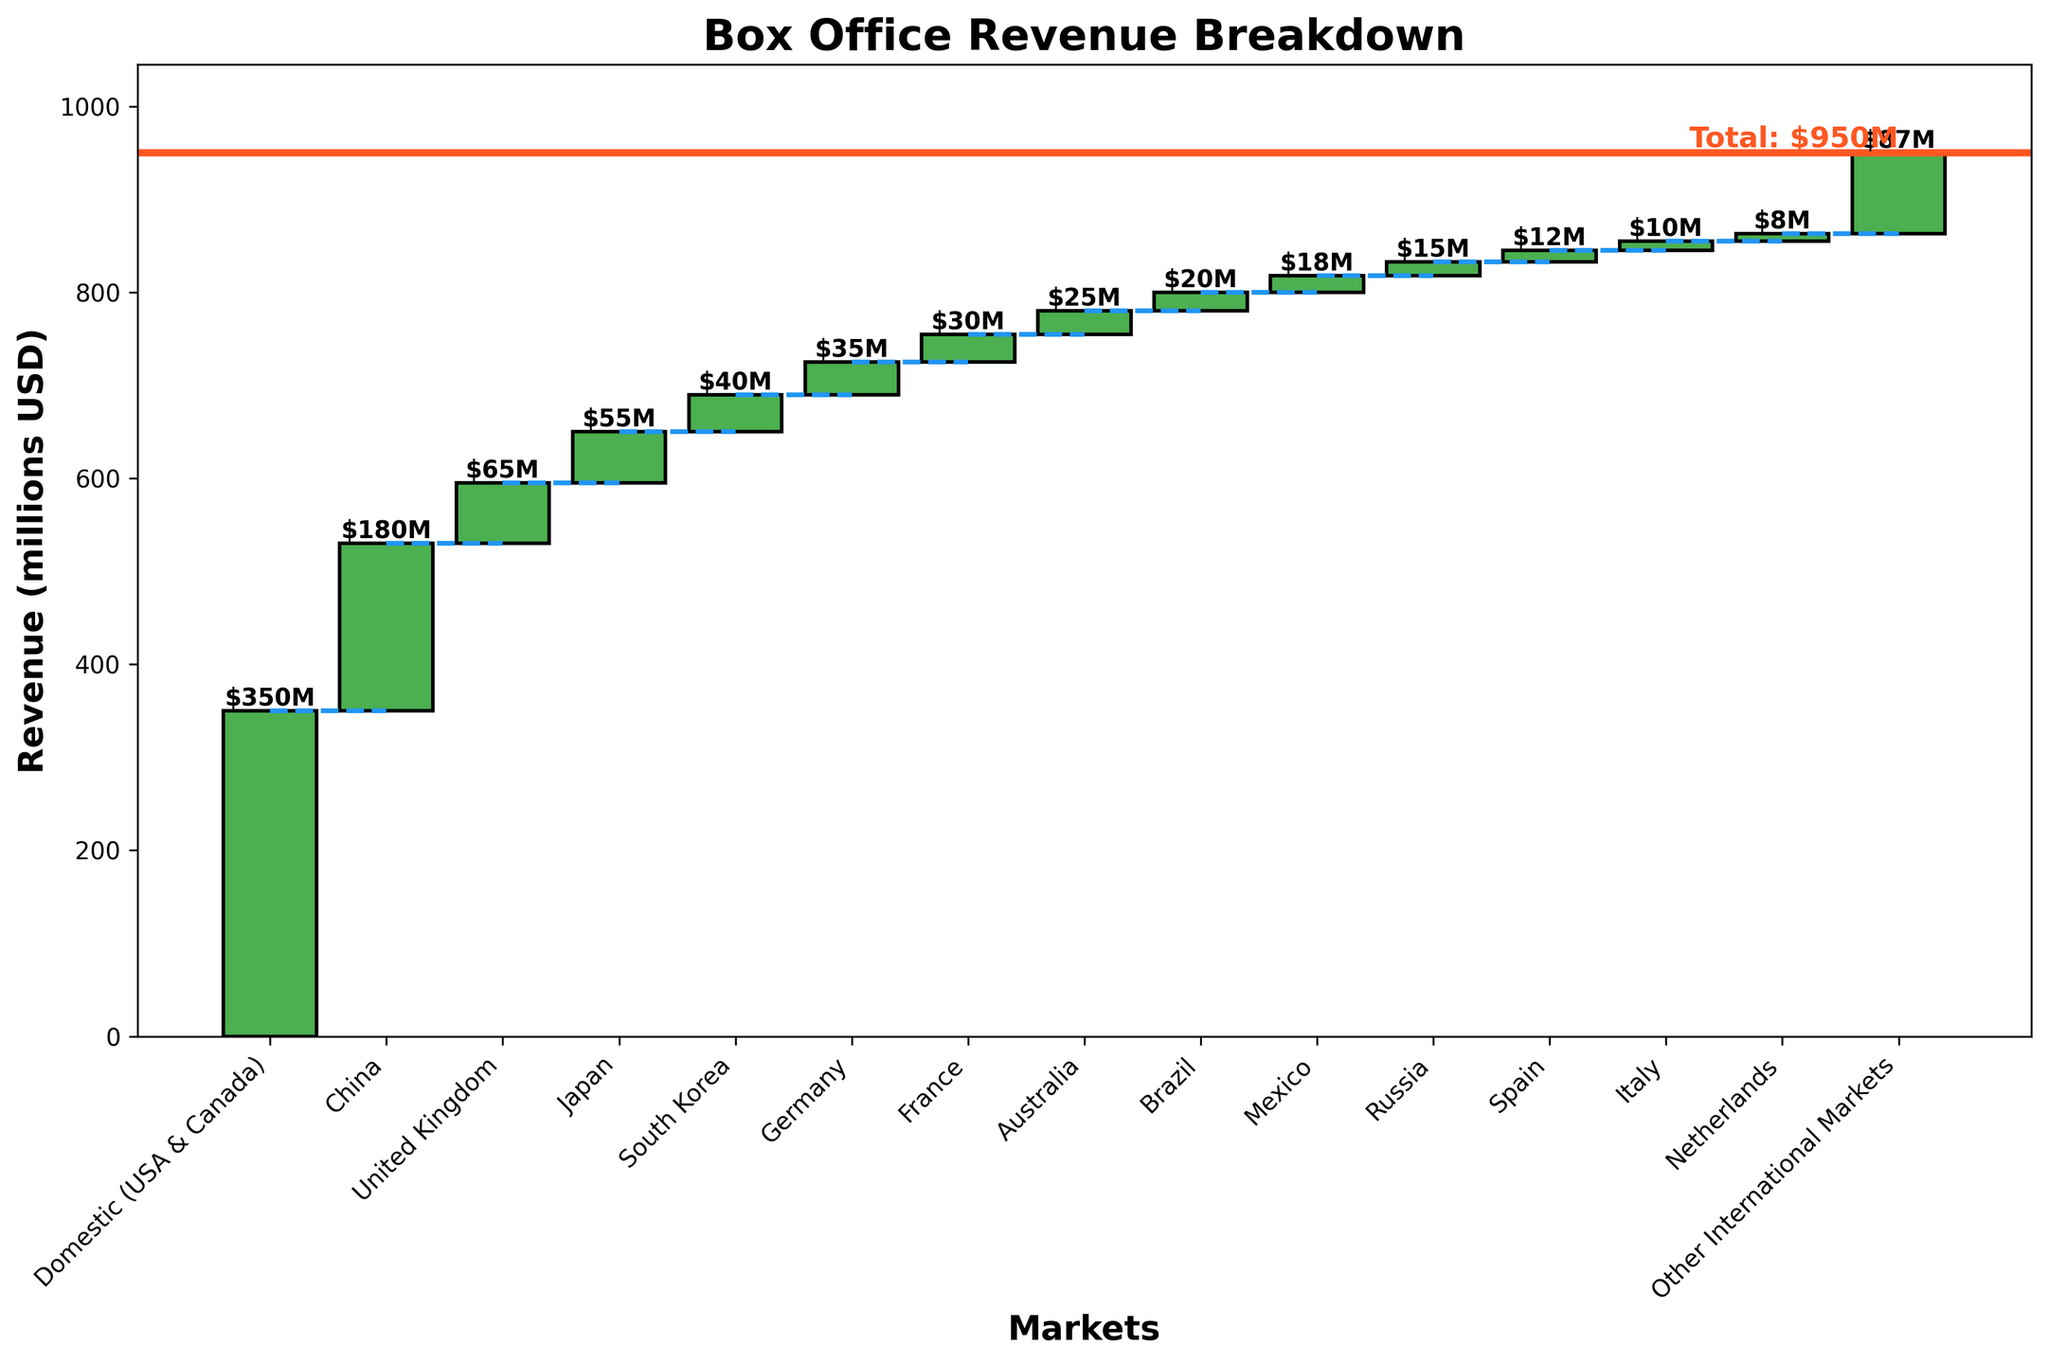What is the title of the plot? The title of the plot is usually found at the top of the figure. In this plot, it is "Box Office Revenue Breakdown".
Answer: Box Office Revenue Breakdown Which market contributed the most to the box office revenue? You can identify the market with the highest revenue by looking for the tallest bar. The Domestic (USA & Canada) market has the tallest bar.
Answer: Domestic (USA & Canada) What is the total revenue shown in the plot? The total revenue is marked by a horizontal line near the top of the plot, and it is labeled as "Total: $950M".
Answer: $950M How many markets are displayed in the plot? Count the number of distinct bars representing different markets. Excluding the total, there are 15 markets listed.
Answer: 15 Which market has the least contribution to the box office revenue? The market with the smallest bar represents the lowest revenue. The market with the least contribution is Italy, at $10M.
Answer: Italy What is the combined revenue from Japan and South Korea? Find the revenues for Japan ($55M) and South Korea ($40M) and sum them up. The combined revenue is $55M + $40M = $95M.
Answer: $95M How does the revenue from Germany compare to that from France? Compare the heights of the bars for Germany (35M) and France (30M). Germany's revenue is higher.
Answer: Germany What is the average revenue from the top three contributing markets? Identify the top three markets (Domestic: $350M, China: $180M, United Kingdom: $65M). Calculate the average: ($350M + $180M + $65M) / 3 = $195M.
Answer: $195M Which market is closest in revenue contribution to Mexico? Look for a bar with a revenue value close to Mexico's $18M. Russia, with $15M, is the closest to Mexico.
Answer: Russia What is the cumulative revenue after adding the first five markets? Sum the revenues of the first five markets: Domestic ($350M), China ($180M), United Kingdom ($65M), Japan ($55M), and South Korea ($40M). The cumulative revenue is $690M.
Answer: $690M 